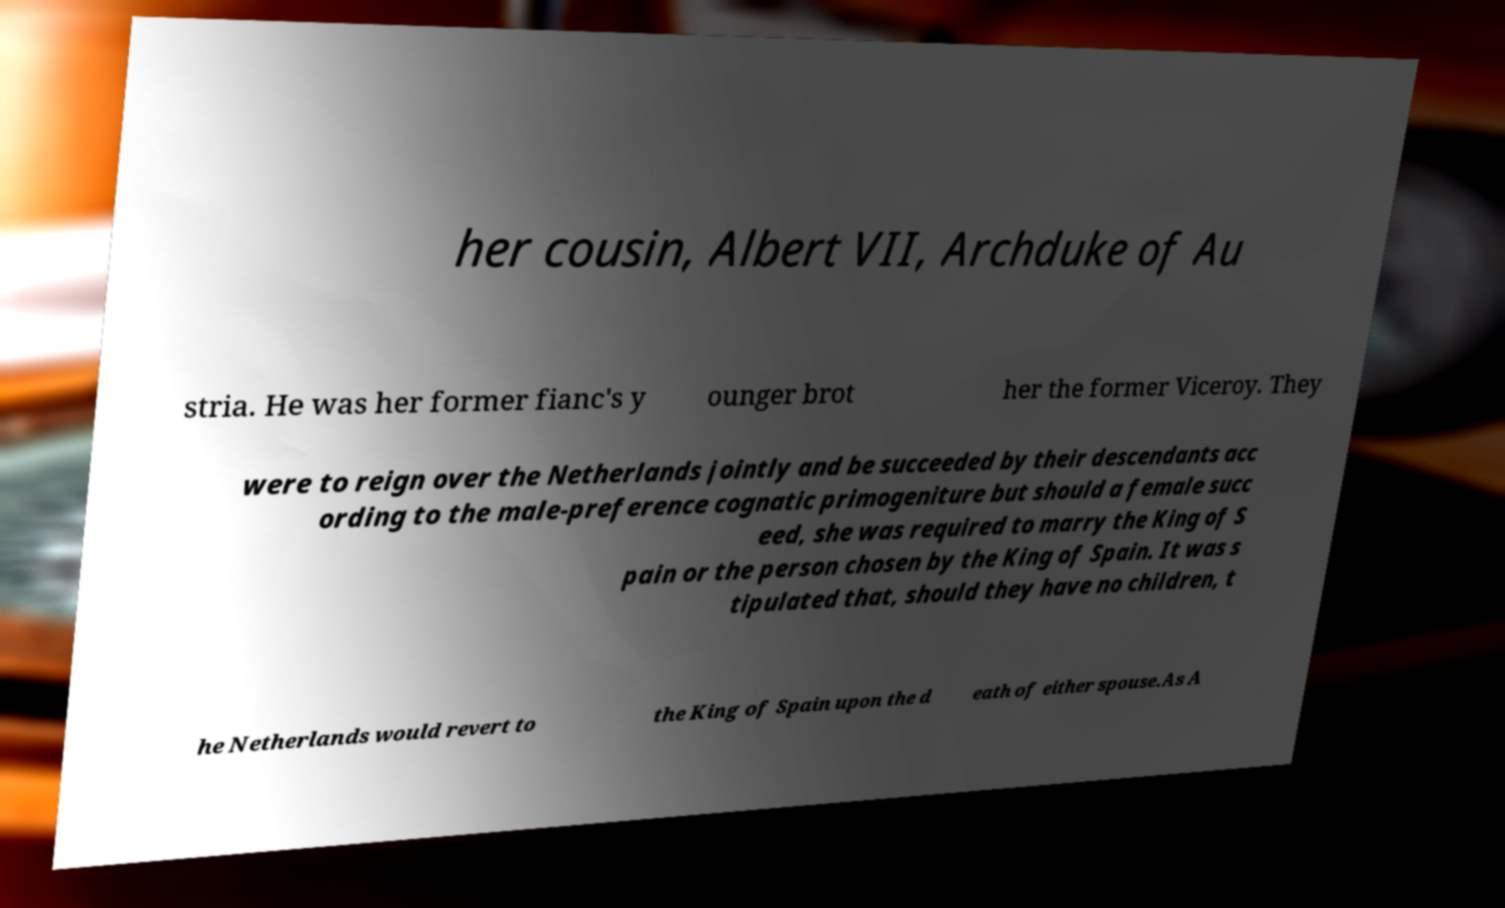Could you extract and type out the text from this image? her cousin, Albert VII, Archduke of Au stria. He was her former fianc's y ounger brot her the former Viceroy. They were to reign over the Netherlands jointly and be succeeded by their descendants acc ording to the male-preference cognatic primogeniture but should a female succ eed, she was required to marry the King of S pain or the person chosen by the King of Spain. It was s tipulated that, should they have no children, t he Netherlands would revert to the King of Spain upon the d eath of either spouse.As A 